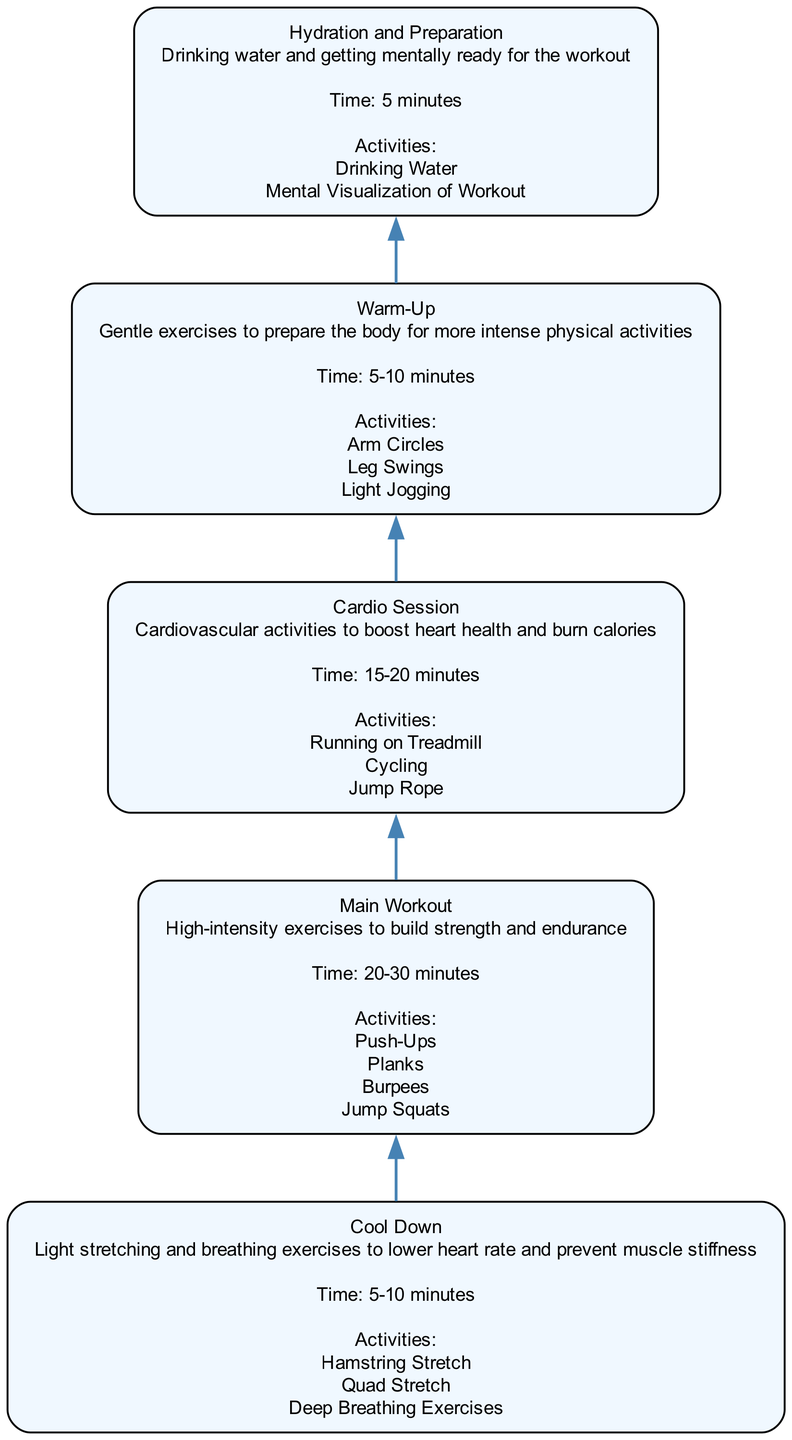What is the first step in the fitness routine? The diagram clearly indicates that the first step in the fitness routine is "Hydration and Preparation," as it is the node at the bottom of the flow chart.
Answer: Hydration and Preparation How long is the Cool Down supposed to last? By analyzing the "Cool Down" node in the diagram, it specifies that the duration for this step is 5-10 minutes.
Answer: 5-10 minutes What activities are listed under the Main Workout? The "Main Workout" node details several activities, including "Push-Ups," "Planks," "Burpees," and "Jump Squats." These activities are explicitly mentioned under its section in the diagram.
Answer: Push-Ups, Planks, Burpees, Jump Squats How many main components are in the fitness routine? The diagram features five distinct nodes representing the components of the fitness routine: Hydration and Preparation, Warm-Up, Main Workout, Cardio Session, and Cool Down. Counting these, we find there are five components.
Answer: 5 What is the purpose of the Warm-Up? According to the description in the "Warm-Up" node, its purpose is to prepare the body for more intense physical activities. This is a key takeaway from the node's description in the diagram.
Answer: To prepare the body for more intense physical activities Which component immediately follows the Warm-Up? Looking at the flow from the bottom to the top of the diagram, the "Main Workout" component is directly above the "Warm-Up," indicating that it follows directly after.
Answer: Main Workout What is the total time suggested for the Main Workout? The "Main Workout" node indicates a time commitment of 20-30 minutes, which is a crucial detail highlighted in the diagram.
Answer: 20-30 minutes What describes the Cardio Session activities? The "Cardio Session" node provides details on activities aimed to boost heart health and burn calories. The activities included are "Running on Treadmill," "Cycling," and "Jump Rope."
Answer: Boost heart health and burn calories 